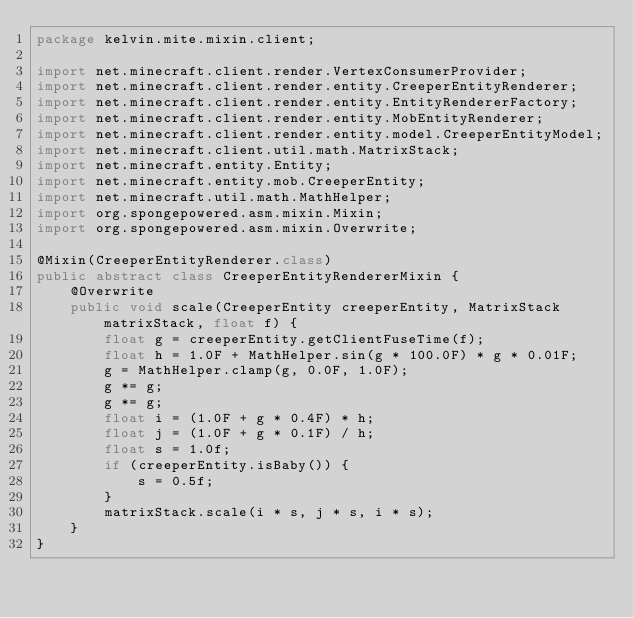<code> <loc_0><loc_0><loc_500><loc_500><_Java_>package kelvin.mite.mixin.client;

import net.minecraft.client.render.VertexConsumerProvider;
import net.minecraft.client.render.entity.CreeperEntityRenderer;
import net.minecraft.client.render.entity.EntityRendererFactory;
import net.minecraft.client.render.entity.MobEntityRenderer;
import net.minecraft.client.render.entity.model.CreeperEntityModel;
import net.minecraft.client.util.math.MatrixStack;
import net.minecraft.entity.Entity;
import net.minecraft.entity.mob.CreeperEntity;
import net.minecraft.util.math.MathHelper;
import org.spongepowered.asm.mixin.Mixin;
import org.spongepowered.asm.mixin.Overwrite;

@Mixin(CreeperEntityRenderer.class)
public abstract class CreeperEntityRendererMixin {
    @Overwrite
    public void scale(CreeperEntity creeperEntity, MatrixStack matrixStack, float f) {
        float g = creeperEntity.getClientFuseTime(f);
        float h = 1.0F + MathHelper.sin(g * 100.0F) * g * 0.01F;
        g = MathHelper.clamp(g, 0.0F, 1.0F);
        g *= g;
        g *= g;
        float i = (1.0F + g * 0.4F) * h;
        float j = (1.0F + g * 0.1F) / h;
        float s = 1.0f;
        if (creeperEntity.isBaby()) {
            s = 0.5f;
        }
        matrixStack.scale(i * s, j * s, i * s);
    }
}
</code> 